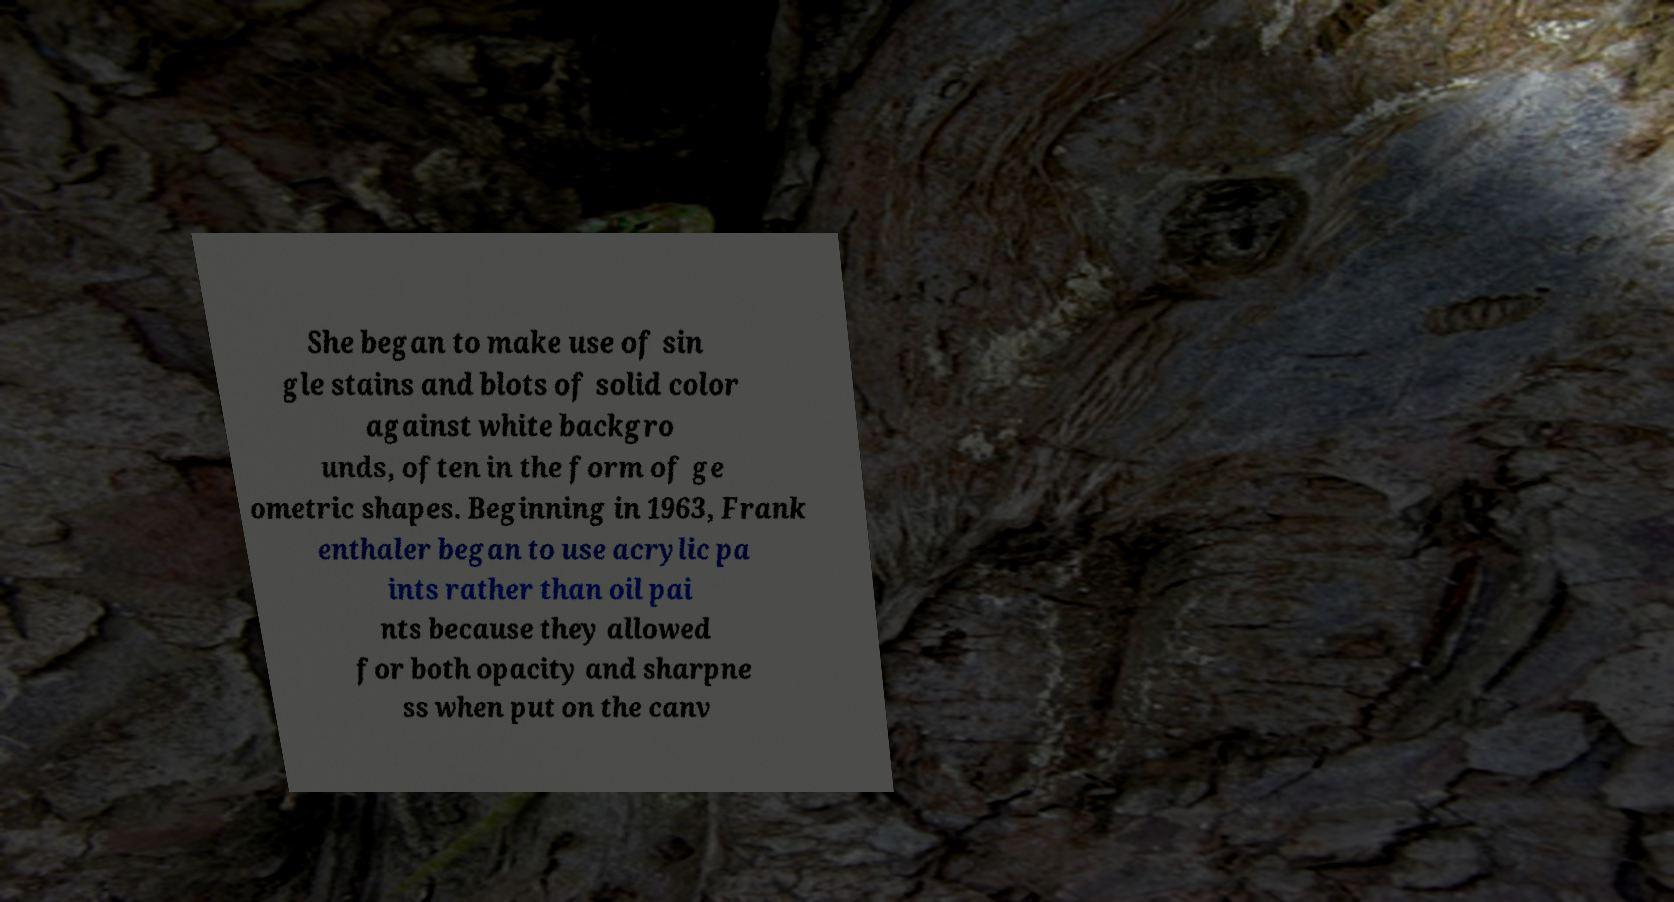Can you accurately transcribe the text from the provided image for me? She began to make use of sin gle stains and blots of solid color against white backgro unds, often in the form of ge ometric shapes. Beginning in 1963, Frank enthaler began to use acrylic pa ints rather than oil pai nts because they allowed for both opacity and sharpne ss when put on the canv 